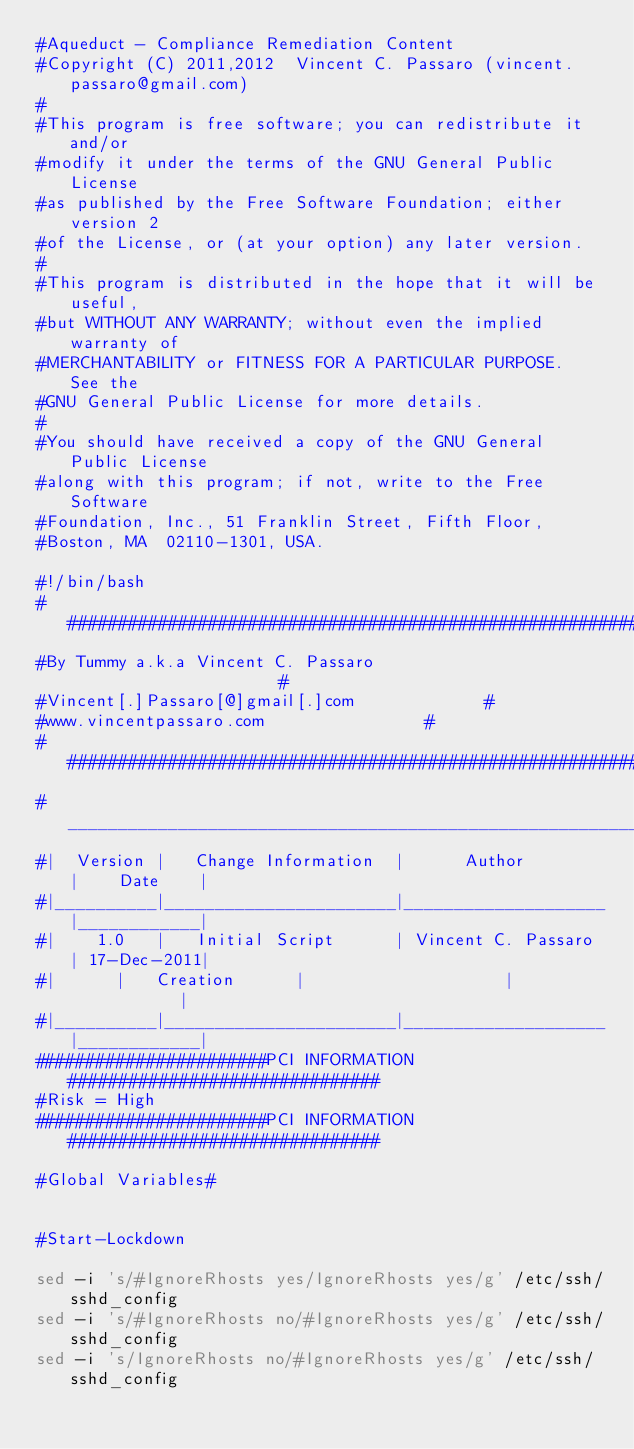Convert code to text. <code><loc_0><loc_0><loc_500><loc_500><_Bash_>#Aqueduct - Compliance Remediation Content
#Copyright (C) 2011,2012  Vincent C. Passaro (vincent.passaro@gmail.com)
#
#This program is free software; you can redistribute it and/or
#modify it under the terms of the GNU General Public License
#as published by the Free Software Foundation; either version 2
#of the License, or (at your option) any later version.
#
#This program is distributed in the hope that it will be useful,
#but WITHOUT ANY WARRANTY; without even the implied warranty of
#MERCHANTABILITY or FITNESS FOR A PARTICULAR PURPOSE.  See the
#GNU General Public License for more details.
#
#You should have received a copy of the GNU General Public License
#along with this program; if not, write to the Free Software
#Foundation, Inc., 51 Franklin Street, Fifth Floor,
#Boston, MA  02110-1301, USA.

#!/bin/bash
######################################################################
#By Tummy a.k.a Vincent C. Passaro		                     #
#Vincent[.]Passaro[@]gmail[.]com				     #
#www.vincentpassaro.com						     #
######################################################################
#_____________________________________________________________________
#|  Version |   Change Information  |      Author        |    Date    |
#|__________|_______________________|____________________|____________|
#|    1.0   |   Initial Script      | Vincent C. Passaro | 17-Dec-2011|
#|	    |   Creation	    |                    |            |
#|__________|_______________________|____________________|____________|
#######################PCI INFORMATION###############################
#Risk = High
#######################PCI INFORMATION###############################

#Global Variables#


#Start-Lockdown

sed -i 's/#IgnoreRhosts yes/IgnoreRhosts yes/g' /etc/ssh/sshd_config
sed -i 's/#IgnoreRhosts no/#IgnoreRhosts yes/g' /etc/ssh/sshd_config
sed -i 's/IgnoreRhosts no/#IgnoreRhosts yes/g' /etc/ssh/sshd_config

</code> 